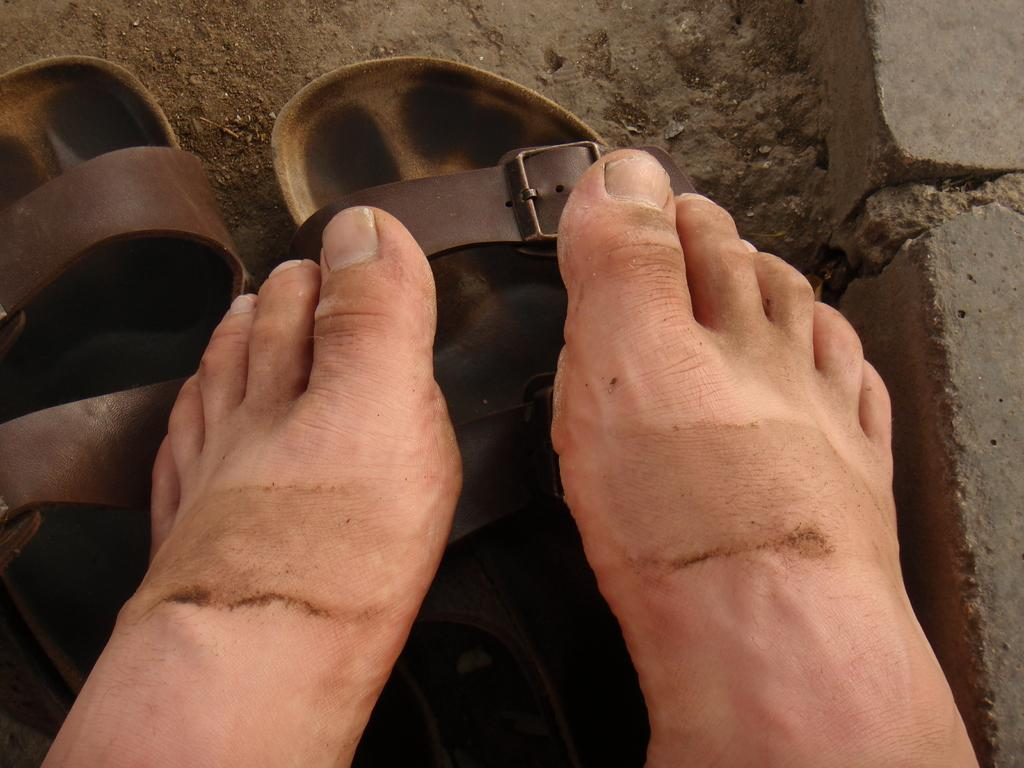What part of a person can be seen in the image? There are legs of a person in the image. What is on the ground near the person's legs? Footwear is visible on the ground. What type of natural element is present on the right side of the image? There are stones on the right side of the image. What is the price of the quill in the image? There is no quill present in the image, so it is not possible to determine its price. 